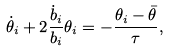Convert formula to latex. <formula><loc_0><loc_0><loc_500><loc_500>\dot { \theta } _ { i } + 2 \frac { \dot { b } _ { i } } { b _ { i } } \theta _ { i } = - \frac { \theta _ { i } - \bar { \theta } } { \tau } ,</formula> 